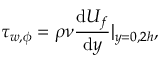<formula> <loc_0><loc_0><loc_500><loc_500>\tau _ { w , \phi } = \rho \nu \frac { d U _ { f } } { d y } | _ { y = 0 , 2 h } ,</formula> 